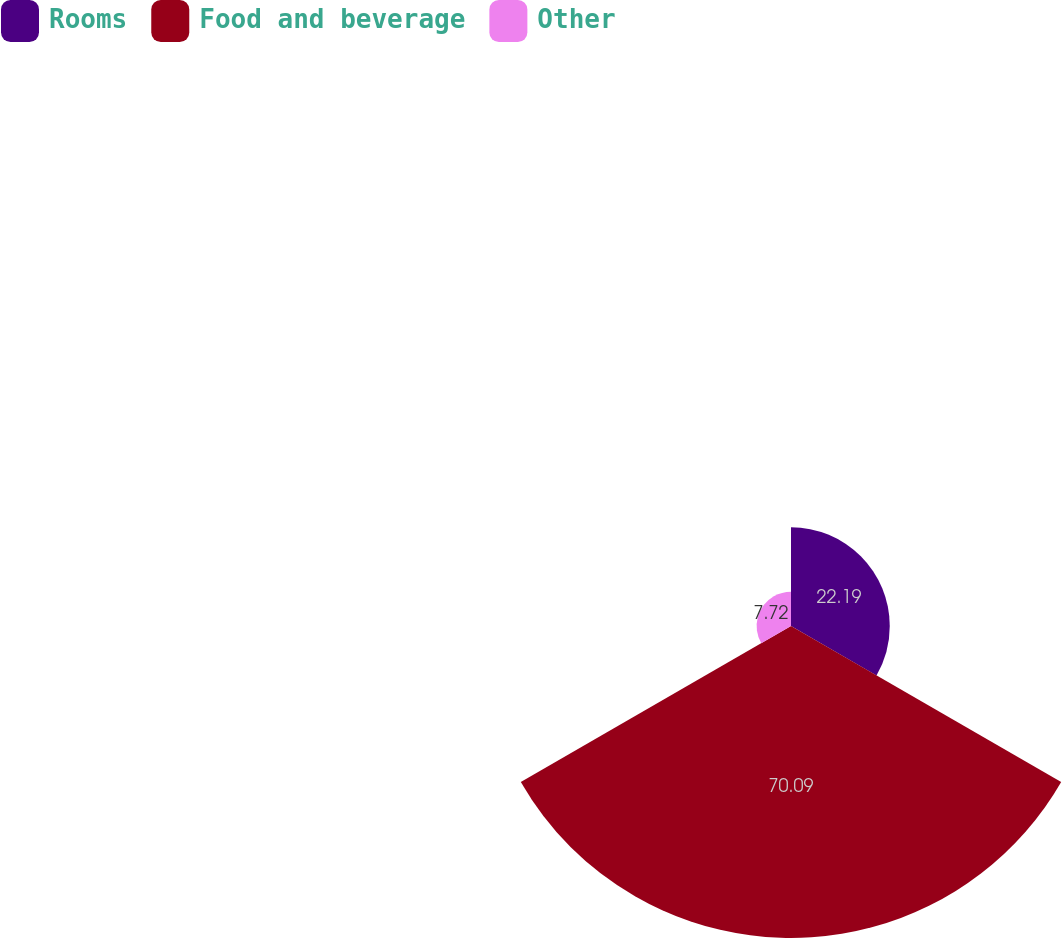<chart> <loc_0><loc_0><loc_500><loc_500><pie_chart><fcel>Rooms<fcel>Food and beverage<fcel>Other<nl><fcel>22.19%<fcel>70.1%<fcel>7.72%<nl></chart> 